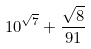Convert formula to latex. <formula><loc_0><loc_0><loc_500><loc_500>1 0 ^ { \sqrt { 7 } } + \frac { \sqrt { 8 } } { 9 1 }</formula> 